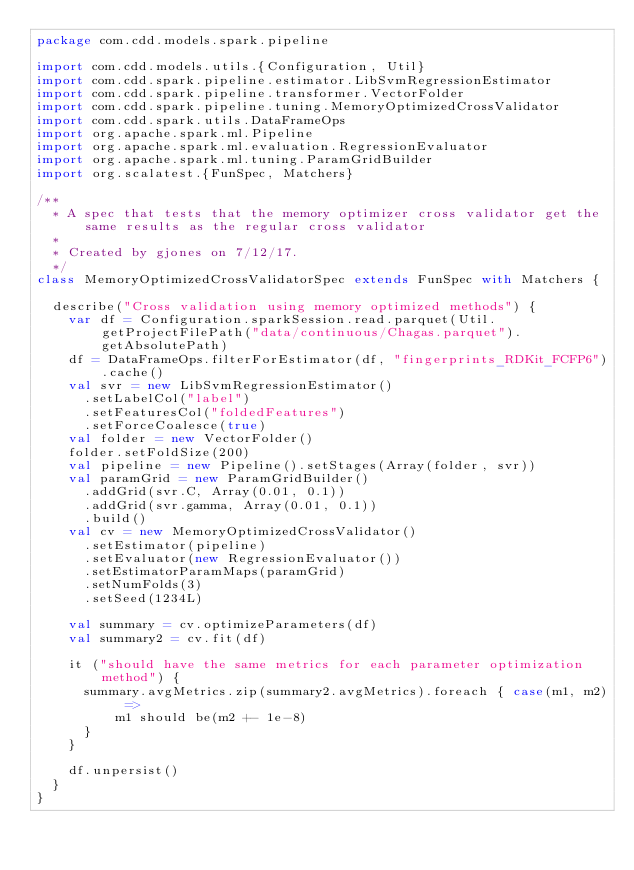<code> <loc_0><loc_0><loc_500><loc_500><_Scala_>package com.cdd.models.spark.pipeline

import com.cdd.models.utils.{Configuration, Util}
import com.cdd.spark.pipeline.estimator.LibSvmRegressionEstimator
import com.cdd.spark.pipeline.transformer.VectorFolder
import com.cdd.spark.pipeline.tuning.MemoryOptimizedCrossValidator
import com.cdd.spark.utils.DataFrameOps
import org.apache.spark.ml.Pipeline
import org.apache.spark.ml.evaluation.RegressionEvaluator
import org.apache.spark.ml.tuning.ParamGridBuilder
import org.scalatest.{FunSpec, Matchers}

/**
  * A spec that tests that the memory optimizer cross validator get the same results as the regular cross validator
  *
  * Created by gjones on 7/12/17.
  */
class MemoryOptimizedCrossValidatorSpec extends FunSpec with Matchers {

  describe("Cross validation using memory optimized methods") {
    var df = Configuration.sparkSession.read.parquet(Util.getProjectFilePath("data/continuous/Chagas.parquet").getAbsolutePath)
    df = DataFrameOps.filterForEstimator(df, "fingerprints_RDKit_FCFP6").cache()
    val svr = new LibSvmRegressionEstimator()
      .setLabelCol("label")
      .setFeaturesCol("foldedFeatures")
      .setForceCoalesce(true)
    val folder = new VectorFolder()
    folder.setFoldSize(200)
    val pipeline = new Pipeline().setStages(Array(folder, svr))
    val paramGrid = new ParamGridBuilder()
      .addGrid(svr.C, Array(0.01, 0.1))
      .addGrid(svr.gamma, Array(0.01, 0.1))
      .build()
    val cv = new MemoryOptimizedCrossValidator()
      .setEstimator(pipeline)
      .setEvaluator(new RegressionEvaluator())
      .setEstimatorParamMaps(paramGrid)
      .setNumFolds(3)
      .setSeed(1234L)

    val summary = cv.optimizeParameters(df)
    val summary2 = cv.fit(df)

    it ("should have the same metrics for each parameter optimization method") {
      summary.avgMetrics.zip(summary2.avgMetrics).foreach { case(m1, m2) =>
          m1 should be(m2 +- 1e-8)
      }
    }

    df.unpersist()
  }
}
</code> 